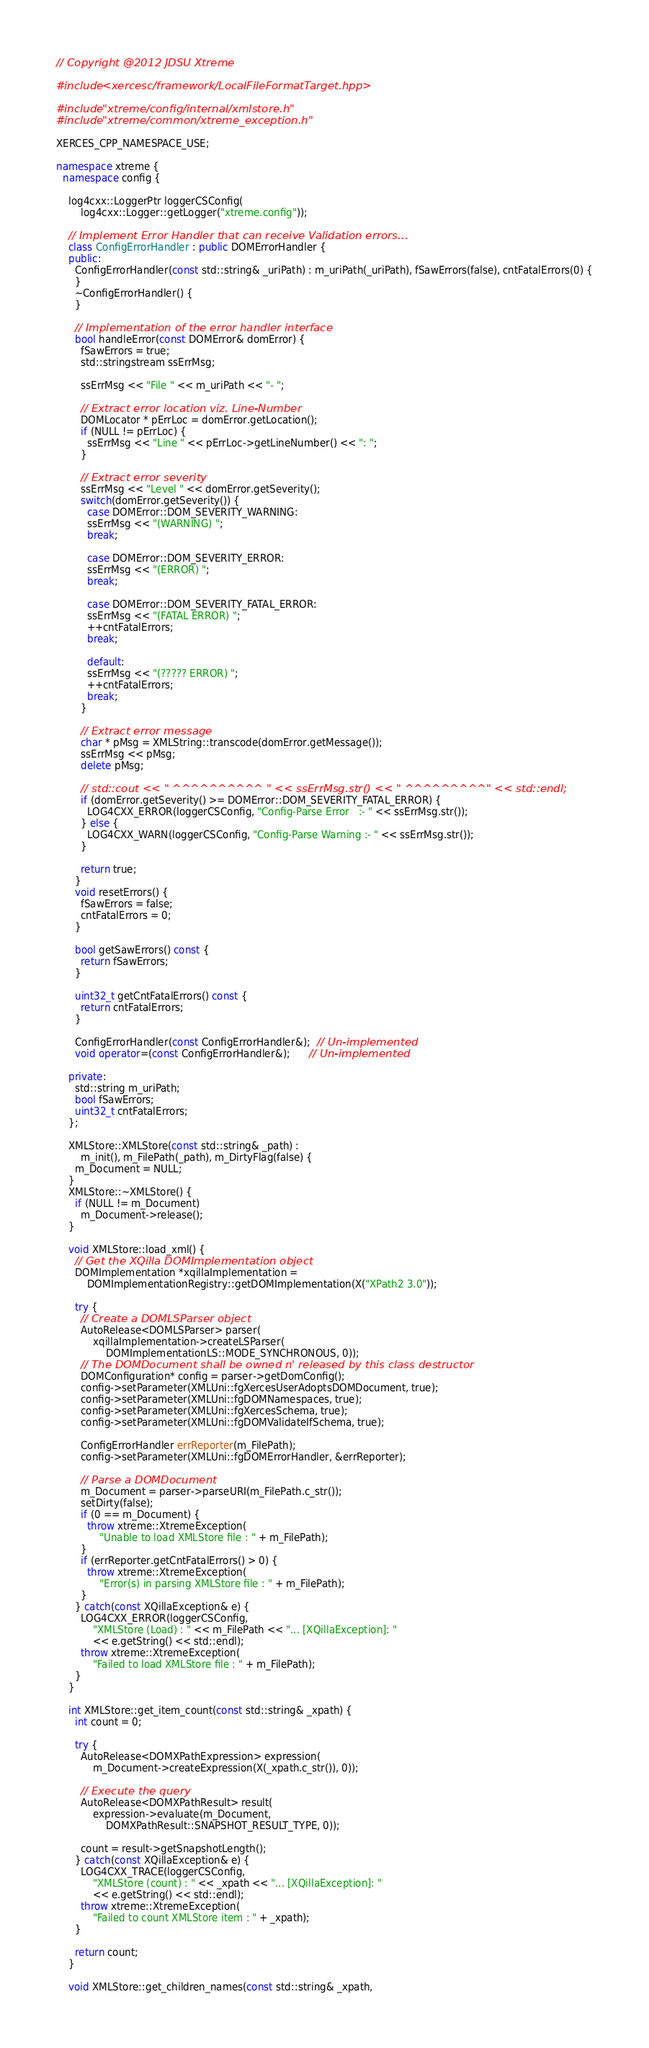Convert code to text. <code><loc_0><loc_0><loc_500><loc_500><_C++_>// Copyright @2012 JDSU Xtreme

#include <xercesc/framework/LocalFileFormatTarget.hpp>

#include "xtreme/config/internal/xmlstore.h"
#include "xtreme/common/xtreme_exception.h"

XERCES_CPP_NAMESPACE_USE;

namespace xtreme {
  namespace config {

    log4cxx::LoggerPtr loggerCSConfig(
        log4cxx::Logger::getLogger("xtreme.config"));

    // Implement Error Handler that can receive Validation errors...
    class ConfigErrorHandler : public DOMErrorHandler {
    public:
      ConfigErrorHandler(const std::string& _uriPath) : m_uriPath(_uriPath), fSawErrors(false), cntFatalErrors(0) {
      }
      ~ConfigErrorHandler() {
      }

      // Implementation of the error handler interface
      bool handleError(const DOMError& domError) {
        fSawErrors = true;
        std::stringstream ssErrMsg;

        ssErrMsg << "File " << m_uriPath << "- ";

        // Extract error location viz. Line-Number
        DOMLocator * pErrLoc = domError.getLocation();
        if (NULL != pErrLoc) {
          ssErrMsg << "Line " << pErrLoc->getLineNumber() << ": ";
        }

        // Extract error severity
        ssErrMsg << "Level " << domError.getSeverity();
        switch(domError.getSeverity()) {
          case DOMError::DOM_SEVERITY_WARNING:
          ssErrMsg << "(WARNING) ";
          break;

          case DOMError::DOM_SEVERITY_ERROR:
          ssErrMsg << "(ERROR) ";
          break;

          case DOMError::DOM_SEVERITY_FATAL_ERROR:
          ssErrMsg << "(FATAL ERROR) ";
          ++cntFatalErrors;
          break;

          default:
          ssErrMsg << "(????? ERROR) ";
          ++cntFatalErrors;
          break;
        }

        // Extract error message
        char * pMsg = XMLString::transcode(domError.getMessage());
        ssErrMsg << pMsg;
        delete pMsg;

        // std::cout << " ^^^^^^^^^^ " << ssErrMsg.str() << " ^^^^^^^^^" << std::endl;
        if (domError.getSeverity() >= DOMError::DOM_SEVERITY_FATAL_ERROR) {
          LOG4CXX_ERROR(loggerCSConfig, "Config-Parse Error   :- " << ssErrMsg.str());
        } else {
          LOG4CXX_WARN(loggerCSConfig, "Config-Parse Warning :- " << ssErrMsg.str());
        }

        return true;
      }
      void resetErrors() {
        fSawErrors = false;
        cntFatalErrors = 0;
      }

      bool getSawErrors() const {
        return fSawErrors;
      }

      uint32_t getCntFatalErrors() const {
        return cntFatalErrors;
      }

      ConfigErrorHandler(const ConfigErrorHandler&);  // Un-implemented
      void operator=(const ConfigErrorHandler&);      // Un-implemented

    private:
      std::string m_uriPath;
      bool fSawErrors;
      uint32_t cntFatalErrors;
    };

    XMLStore::XMLStore(const std::string& _path) :
        m_init(), m_FilePath(_path), m_DirtyFlag(false) {
      m_Document = NULL;
    }
    XMLStore::~XMLStore() {
      if (NULL != m_Document)
        m_Document->release();
    }

    void XMLStore::load_xml() {
      // Get the XQilla DOMImplementation object
      DOMImplementation *xqillaImplementation =
          DOMImplementationRegistry::getDOMImplementation(X("XPath2 3.0"));

      try {
        // Create a DOMLSParser object
        AutoRelease<DOMLSParser> parser(
            xqillaImplementation->createLSParser(
                DOMImplementationLS::MODE_SYNCHRONOUS, 0));
        // The DOMDocument shall be owned n' released by this class destructor
        DOMConfiguration* config = parser->getDomConfig();
        config->setParameter(XMLUni::fgXercesUserAdoptsDOMDocument, true);
        config->setParameter(XMLUni::fgDOMNamespaces, true);
        config->setParameter(XMLUni::fgXercesSchema, true);
        config->setParameter(XMLUni::fgDOMValidateIfSchema, true);

        ConfigErrorHandler errReporter(m_FilePath);
        config->setParameter(XMLUni::fgDOMErrorHandler, &errReporter);

        // Parse a DOMDocument
        m_Document = parser->parseURI(m_FilePath.c_str());
        setDirty(false);
        if (0 == m_Document) {
          throw xtreme::XtremeException(
              "Unable to load XMLStore file : " + m_FilePath);
        }
        if (errReporter.getCntFatalErrors() > 0) {
          throw xtreme::XtremeException(
              "Error(s) in parsing XMLStore file : " + m_FilePath);
        }
      } catch(const XQillaException& e) {
        LOG4CXX_ERROR(loggerCSConfig,
            "XMLStore (Load) : " << m_FilePath << "... [XQillaException]: "
            << e.getString() << std::endl);
        throw xtreme::XtremeException(
            "Failed to load XMLStore file : " + m_FilePath);
      }
    }

    int XMLStore::get_item_count(const std::string& _xpath) {
      int count = 0;

      try {
        AutoRelease<DOMXPathExpression> expression(
            m_Document->createExpression(X(_xpath.c_str()), 0));

        // Execute the query
        AutoRelease<DOMXPathResult> result(
            expression->evaluate(m_Document,
                DOMXPathResult::SNAPSHOT_RESULT_TYPE, 0));

        count = result->getSnapshotLength();
      } catch(const XQillaException& e) {
        LOG4CXX_TRACE(loggerCSConfig,
            "XMLStore (count) : " << _xpath << "... [XQillaException]: "
            << e.getString() << std::endl);
        throw xtreme::XtremeException(
            "Failed to count XMLStore item : " + _xpath);
      }

      return count;
    }

    void XMLStore::get_children_names(const std::string& _xpath,</code> 